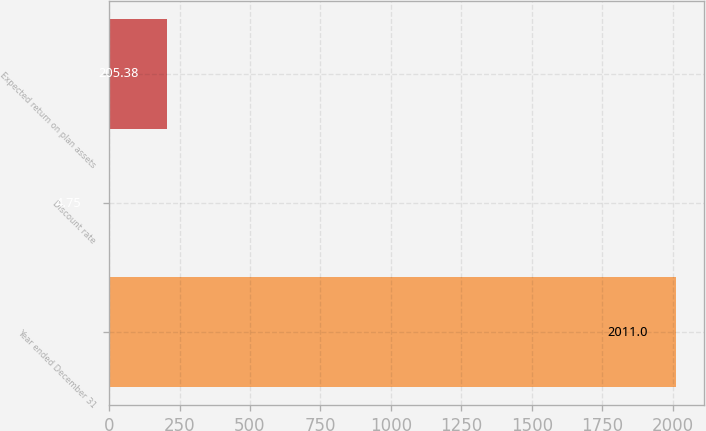<chart> <loc_0><loc_0><loc_500><loc_500><bar_chart><fcel>Year ended December 31<fcel>Discount rate<fcel>Expected return on plan assets<nl><fcel>2011<fcel>4.75<fcel>205.38<nl></chart> 